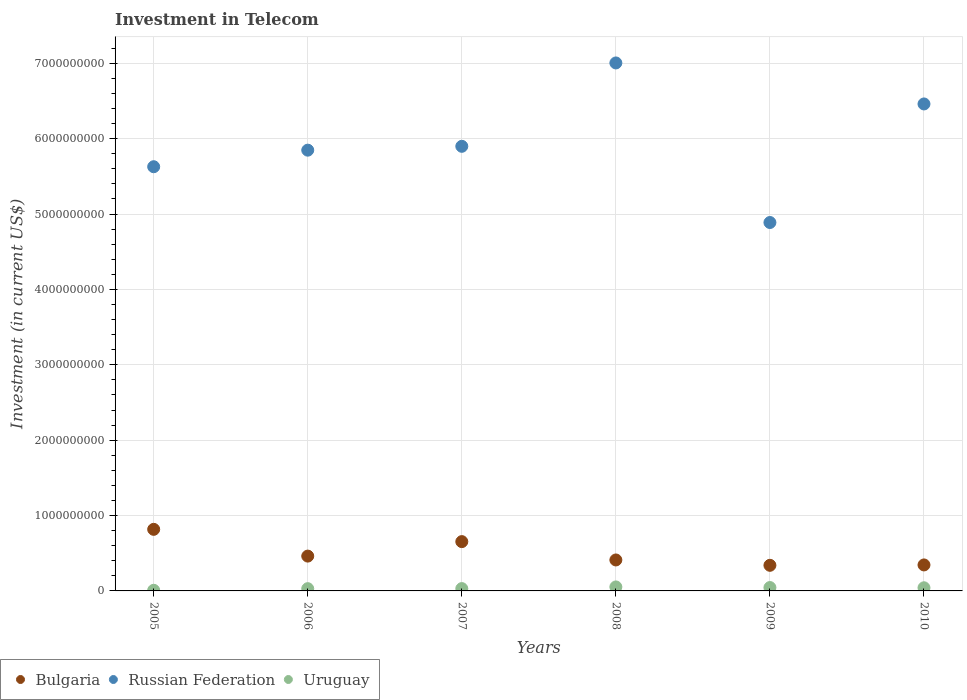How many different coloured dotlines are there?
Your response must be concise. 3. Is the number of dotlines equal to the number of legend labels?
Offer a very short reply. Yes. What is the amount invested in telecom in Russian Federation in 2006?
Give a very brief answer. 5.85e+09. Across all years, what is the maximum amount invested in telecom in Uruguay?
Provide a succinct answer. 5.29e+07. Across all years, what is the minimum amount invested in telecom in Uruguay?
Ensure brevity in your answer.  8.40e+06. What is the total amount invested in telecom in Russian Federation in the graph?
Provide a succinct answer. 3.57e+1. What is the difference between the amount invested in telecom in Bulgaria in 2005 and that in 2010?
Your answer should be compact. 4.72e+08. What is the difference between the amount invested in telecom in Bulgaria in 2006 and the amount invested in telecom in Russian Federation in 2005?
Your response must be concise. -5.17e+09. What is the average amount invested in telecom in Bulgaria per year?
Offer a very short reply. 5.05e+08. In the year 2010, what is the difference between the amount invested in telecom in Uruguay and amount invested in telecom in Russian Federation?
Offer a very short reply. -6.42e+09. What is the ratio of the amount invested in telecom in Bulgaria in 2006 to that in 2008?
Your answer should be very brief. 1.12. Is the difference between the amount invested in telecom in Uruguay in 2006 and 2010 greater than the difference between the amount invested in telecom in Russian Federation in 2006 and 2010?
Provide a short and direct response. Yes. What is the difference between the highest and the second highest amount invested in telecom in Bulgaria?
Make the answer very short. 1.63e+08. What is the difference between the highest and the lowest amount invested in telecom in Bulgaria?
Provide a short and direct response. 4.77e+08. In how many years, is the amount invested in telecom in Uruguay greater than the average amount invested in telecom in Uruguay taken over all years?
Make the answer very short. 3. Is the sum of the amount invested in telecom in Bulgaria in 2007 and 2009 greater than the maximum amount invested in telecom in Uruguay across all years?
Offer a terse response. Yes. Is it the case that in every year, the sum of the amount invested in telecom in Bulgaria and amount invested in telecom in Uruguay  is greater than the amount invested in telecom in Russian Federation?
Offer a terse response. No. Does the amount invested in telecom in Russian Federation monotonically increase over the years?
Offer a very short reply. No. Is the amount invested in telecom in Russian Federation strictly greater than the amount invested in telecom in Uruguay over the years?
Your answer should be very brief. Yes. Is the amount invested in telecom in Uruguay strictly less than the amount invested in telecom in Bulgaria over the years?
Ensure brevity in your answer.  Yes. How many years are there in the graph?
Make the answer very short. 6. Are the values on the major ticks of Y-axis written in scientific E-notation?
Offer a very short reply. No. How many legend labels are there?
Your response must be concise. 3. What is the title of the graph?
Offer a terse response. Investment in Telecom. What is the label or title of the Y-axis?
Make the answer very short. Investment (in current US$). What is the Investment (in current US$) in Bulgaria in 2005?
Your answer should be compact. 8.17e+08. What is the Investment (in current US$) in Russian Federation in 2005?
Give a very brief answer. 5.63e+09. What is the Investment (in current US$) of Uruguay in 2005?
Your answer should be very brief. 8.40e+06. What is the Investment (in current US$) of Bulgaria in 2006?
Offer a terse response. 4.62e+08. What is the Investment (in current US$) in Russian Federation in 2006?
Give a very brief answer. 5.85e+09. What is the Investment (in current US$) in Uruguay in 2006?
Your response must be concise. 3.00e+07. What is the Investment (in current US$) in Bulgaria in 2007?
Offer a very short reply. 6.54e+08. What is the Investment (in current US$) in Russian Federation in 2007?
Your response must be concise. 5.90e+09. What is the Investment (in current US$) of Uruguay in 2007?
Your answer should be very brief. 3.09e+07. What is the Investment (in current US$) of Bulgaria in 2008?
Give a very brief answer. 4.11e+08. What is the Investment (in current US$) in Russian Federation in 2008?
Ensure brevity in your answer.  7.00e+09. What is the Investment (in current US$) of Uruguay in 2008?
Provide a succinct answer. 5.29e+07. What is the Investment (in current US$) in Bulgaria in 2009?
Offer a terse response. 3.40e+08. What is the Investment (in current US$) of Russian Federation in 2009?
Offer a very short reply. 4.89e+09. What is the Investment (in current US$) in Uruguay in 2009?
Make the answer very short. 4.47e+07. What is the Investment (in current US$) in Bulgaria in 2010?
Offer a very short reply. 3.45e+08. What is the Investment (in current US$) of Russian Federation in 2010?
Offer a very short reply. 6.46e+09. What is the Investment (in current US$) in Uruguay in 2010?
Provide a succinct answer. 4.17e+07. Across all years, what is the maximum Investment (in current US$) of Bulgaria?
Offer a terse response. 8.17e+08. Across all years, what is the maximum Investment (in current US$) in Russian Federation?
Ensure brevity in your answer.  7.00e+09. Across all years, what is the maximum Investment (in current US$) of Uruguay?
Provide a succinct answer. 5.29e+07. Across all years, what is the minimum Investment (in current US$) of Bulgaria?
Give a very brief answer. 3.40e+08. Across all years, what is the minimum Investment (in current US$) of Russian Federation?
Your answer should be very brief. 4.89e+09. Across all years, what is the minimum Investment (in current US$) in Uruguay?
Provide a short and direct response. 8.40e+06. What is the total Investment (in current US$) of Bulgaria in the graph?
Your answer should be compact. 3.03e+09. What is the total Investment (in current US$) in Russian Federation in the graph?
Ensure brevity in your answer.  3.57e+1. What is the total Investment (in current US$) in Uruguay in the graph?
Provide a short and direct response. 2.09e+08. What is the difference between the Investment (in current US$) in Bulgaria in 2005 and that in 2006?
Give a very brief answer. 3.55e+08. What is the difference between the Investment (in current US$) of Russian Federation in 2005 and that in 2006?
Provide a short and direct response. -2.20e+08. What is the difference between the Investment (in current US$) in Uruguay in 2005 and that in 2006?
Provide a succinct answer. -2.16e+07. What is the difference between the Investment (in current US$) of Bulgaria in 2005 and that in 2007?
Offer a terse response. 1.63e+08. What is the difference between the Investment (in current US$) of Russian Federation in 2005 and that in 2007?
Your response must be concise. -2.71e+08. What is the difference between the Investment (in current US$) in Uruguay in 2005 and that in 2007?
Offer a terse response. -2.25e+07. What is the difference between the Investment (in current US$) in Bulgaria in 2005 and that in 2008?
Provide a short and direct response. 4.06e+08. What is the difference between the Investment (in current US$) in Russian Federation in 2005 and that in 2008?
Keep it short and to the point. -1.38e+09. What is the difference between the Investment (in current US$) of Uruguay in 2005 and that in 2008?
Provide a short and direct response. -4.45e+07. What is the difference between the Investment (in current US$) of Bulgaria in 2005 and that in 2009?
Keep it short and to the point. 4.77e+08. What is the difference between the Investment (in current US$) in Russian Federation in 2005 and that in 2009?
Provide a short and direct response. 7.40e+08. What is the difference between the Investment (in current US$) in Uruguay in 2005 and that in 2009?
Ensure brevity in your answer.  -3.63e+07. What is the difference between the Investment (in current US$) of Bulgaria in 2005 and that in 2010?
Keep it short and to the point. 4.72e+08. What is the difference between the Investment (in current US$) in Russian Federation in 2005 and that in 2010?
Provide a short and direct response. -8.33e+08. What is the difference between the Investment (in current US$) of Uruguay in 2005 and that in 2010?
Offer a very short reply. -3.33e+07. What is the difference between the Investment (in current US$) in Bulgaria in 2006 and that in 2007?
Your response must be concise. -1.92e+08. What is the difference between the Investment (in current US$) of Russian Federation in 2006 and that in 2007?
Ensure brevity in your answer.  -5.11e+07. What is the difference between the Investment (in current US$) of Uruguay in 2006 and that in 2007?
Make the answer very short. -9.00e+05. What is the difference between the Investment (in current US$) in Bulgaria in 2006 and that in 2008?
Your answer should be compact. 5.12e+07. What is the difference between the Investment (in current US$) in Russian Federation in 2006 and that in 2008?
Ensure brevity in your answer.  -1.16e+09. What is the difference between the Investment (in current US$) of Uruguay in 2006 and that in 2008?
Offer a very short reply. -2.29e+07. What is the difference between the Investment (in current US$) in Bulgaria in 2006 and that in 2009?
Offer a terse response. 1.22e+08. What is the difference between the Investment (in current US$) in Russian Federation in 2006 and that in 2009?
Provide a short and direct response. 9.60e+08. What is the difference between the Investment (in current US$) of Uruguay in 2006 and that in 2009?
Ensure brevity in your answer.  -1.47e+07. What is the difference between the Investment (in current US$) in Bulgaria in 2006 and that in 2010?
Keep it short and to the point. 1.17e+08. What is the difference between the Investment (in current US$) in Russian Federation in 2006 and that in 2010?
Your answer should be compact. -6.13e+08. What is the difference between the Investment (in current US$) of Uruguay in 2006 and that in 2010?
Offer a terse response. -1.17e+07. What is the difference between the Investment (in current US$) in Bulgaria in 2007 and that in 2008?
Ensure brevity in your answer.  2.43e+08. What is the difference between the Investment (in current US$) in Russian Federation in 2007 and that in 2008?
Make the answer very short. -1.11e+09. What is the difference between the Investment (in current US$) of Uruguay in 2007 and that in 2008?
Ensure brevity in your answer.  -2.20e+07. What is the difference between the Investment (in current US$) of Bulgaria in 2007 and that in 2009?
Keep it short and to the point. 3.14e+08. What is the difference between the Investment (in current US$) in Russian Federation in 2007 and that in 2009?
Your answer should be compact. 1.01e+09. What is the difference between the Investment (in current US$) in Uruguay in 2007 and that in 2009?
Provide a succinct answer. -1.38e+07. What is the difference between the Investment (in current US$) in Bulgaria in 2007 and that in 2010?
Offer a very short reply. 3.09e+08. What is the difference between the Investment (in current US$) in Russian Federation in 2007 and that in 2010?
Make the answer very short. -5.62e+08. What is the difference between the Investment (in current US$) of Uruguay in 2007 and that in 2010?
Give a very brief answer. -1.08e+07. What is the difference between the Investment (in current US$) of Bulgaria in 2008 and that in 2009?
Offer a very short reply. 7.11e+07. What is the difference between the Investment (in current US$) of Russian Federation in 2008 and that in 2009?
Offer a terse response. 2.12e+09. What is the difference between the Investment (in current US$) in Uruguay in 2008 and that in 2009?
Provide a short and direct response. 8.20e+06. What is the difference between the Investment (in current US$) of Bulgaria in 2008 and that in 2010?
Offer a terse response. 6.60e+07. What is the difference between the Investment (in current US$) in Russian Federation in 2008 and that in 2010?
Your answer should be compact. 5.44e+08. What is the difference between the Investment (in current US$) of Uruguay in 2008 and that in 2010?
Make the answer very short. 1.12e+07. What is the difference between the Investment (in current US$) in Bulgaria in 2009 and that in 2010?
Make the answer very short. -5.10e+06. What is the difference between the Investment (in current US$) of Russian Federation in 2009 and that in 2010?
Provide a short and direct response. -1.57e+09. What is the difference between the Investment (in current US$) in Uruguay in 2009 and that in 2010?
Your answer should be very brief. 3.00e+06. What is the difference between the Investment (in current US$) of Bulgaria in 2005 and the Investment (in current US$) of Russian Federation in 2006?
Provide a short and direct response. -5.03e+09. What is the difference between the Investment (in current US$) of Bulgaria in 2005 and the Investment (in current US$) of Uruguay in 2006?
Your answer should be very brief. 7.87e+08. What is the difference between the Investment (in current US$) of Russian Federation in 2005 and the Investment (in current US$) of Uruguay in 2006?
Your response must be concise. 5.60e+09. What is the difference between the Investment (in current US$) of Bulgaria in 2005 and the Investment (in current US$) of Russian Federation in 2007?
Provide a succinct answer. -5.08e+09. What is the difference between the Investment (in current US$) of Bulgaria in 2005 and the Investment (in current US$) of Uruguay in 2007?
Your answer should be compact. 7.86e+08. What is the difference between the Investment (in current US$) in Russian Federation in 2005 and the Investment (in current US$) in Uruguay in 2007?
Make the answer very short. 5.60e+09. What is the difference between the Investment (in current US$) in Bulgaria in 2005 and the Investment (in current US$) in Russian Federation in 2008?
Make the answer very short. -6.19e+09. What is the difference between the Investment (in current US$) of Bulgaria in 2005 and the Investment (in current US$) of Uruguay in 2008?
Provide a short and direct response. 7.64e+08. What is the difference between the Investment (in current US$) in Russian Federation in 2005 and the Investment (in current US$) in Uruguay in 2008?
Offer a terse response. 5.57e+09. What is the difference between the Investment (in current US$) in Bulgaria in 2005 and the Investment (in current US$) in Russian Federation in 2009?
Offer a very short reply. -4.07e+09. What is the difference between the Investment (in current US$) of Bulgaria in 2005 and the Investment (in current US$) of Uruguay in 2009?
Give a very brief answer. 7.72e+08. What is the difference between the Investment (in current US$) of Russian Federation in 2005 and the Investment (in current US$) of Uruguay in 2009?
Keep it short and to the point. 5.58e+09. What is the difference between the Investment (in current US$) of Bulgaria in 2005 and the Investment (in current US$) of Russian Federation in 2010?
Your answer should be very brief. -5.64e+09. What is the difference between the Investment (in current US$) of Bulgaria in 2005 and the Investment (in current US$) of Uruguay in 2010?
Your response must be concise. 7.75e+08. What is the difference between the Investment (in current US$) of Russian Federation in 2005 and the Investment (in current US$) of Uruguay in 2010?
Offer a very short reply. 5.59e+09. What is the difference between the Investment (in current US$) of Bulgaria in 2006 and the Investment (in current US$) of Russian Federation in 2007?
Your answer should be compact. -5.44e+09. What is the difference between the Investment (in current US$) of Bulgaria in 2006 and the Investment (in current US$) of Uruguay in 2007?
Provide a succinct answer. 4.31e+08. What is the difference between the Investment (in current US$) of Russian Federation in 2006 and the Investment (in current US$) of Uruguay in 2007?
Give a very brief answer. 5.82e+09. What is the difference between the Investment (in current US$) of Bulgaria in 2006 and the Investment (in current US$) of Russian Federation in 2008?
Your answer should be very brief. -6.54e+09. What is the difference between the Investment (in current US$) in Bulgaria in 2006 and the Investment (in current US$) in Uruguay in 2008?
Keep it short and to the point. 4.09e+08. What is the difference between the Investment (in current US$) in Russian Federation in 2006 and the Investment (in current US$) in Uruguay in 2008?
Provide a short and direct response. 5.79e+09. What is the difference between the Investment (in current US$) in Bulgaria in 2006 and the Investment (in current US$) in Russian Federation in 2009?
Provide a short and direct response. -4.43e+09. What is the difference between the Investment (in current US$) in Bulgaria in 2006 and the Investment (in current US$) in Uruguay in 2009?
Provide a succinct answer. 4.17e+08. What is the difference between the Investment (in current US$) in Russian Federation in 2006 and the Investment (in current US$) in Uruguay in 2009?
Provide a short and direct response. 5.80e+09. What is the difference between the Investment (in current US$) of Bulgaria in 2006 and the Investment (in current US$) of Russian Federation in 2010?
Your answer should be very brief. -6.00e+09. What is the difference between the Investment (in current US$) of Bulgaria in 2006 and the Investment (in current US$) of Uruguay in 2010?
Offer a terse response. 4.20e+08. What is the difference between the Investment (in current US$) in Russian Federation in 2006 and the Investment (in current US$) in Uruguay in 2010?
Ensure brevity in your answer.  5.81e+09. What is the difference between the Investment (in current US$) in Bulgaria in 2007 and the Investment (in current US$) in Russian Federation in 2008?
Your answer should be very brief. -6.35e+09. What is the difference between the Investment (in current US$) of Bulgaria in 2007 and the Investment (in current US$) of Uruguay in 2008?
Your answer should be compact. 6.01e+08. What is the difference between the Investment (in current US$) of Russian Federation in 2007 and the Investment (in current US$) of Uruguay in 2008?
Provide a succinct answer. 5.85e+09. What is the difference between the Investment (in current US$) of Bulgaria in 2007 and the Investment (in current US$) of Russian Federation in 2009?
Offer a very short reply. -4.23e+09. What is the difference between the Investment (in current US$) of Bulgaria in 2007 and the Investment (in current US$) of Uruguay in 2009?
Offer a very short reply. 6.09e+08. What is the difference between the Investment (in current US$) in Russian Federation in 2007 and the Investment (in current US$) in Uruguay in 2009?
Provide a short and direct response. 5.85e+09. What is the difference between the Investment (in current US$) in Bulgaria in 2007 and the Investment (in current US$) in Russian Federation in 2010?
Your answer should be compact. -5.81e+09. What is the difference between the Investment (in current US$) in Bulgaria in 2007 and the Investment (in current US$) in Uruguay in 2010?
Ensure brevity in your answer.  6.12e+08. What is the difference between the Investment (in current US$) of Russian Federation in 2007 and the Investment (in current US$) of Uruguay in 2010?
Provide a succinct answer. 5.86e+09. What is the difference between the Investment (in current US$) of Bulgaria in 2008 and the Investment (in current US$) of Russian Federation in 2009?
Keep it short and to the point. -4.48e+09. What is the difference between the Investment (in current US$) of Bulgaria in 2008 and the Investment (in current US$) of Uruguay in 2009?
Offer a terse response. 3.66e+08. What is the difference between the Investment (in current US$) in Russian Federation in 2008 and the Investment (in current US$) in Uruguay in 2009?
Offer a very short reply. 6.96e+09. What is the difference between the Investment (in current US$) in Bulgaria in 2008 and the Investment (in current US$) in Russian Federation in 2010?
Your answer should be compact. -6.05e+09. What is the difference between the Investment (in current US$) of Bulgaria in 2008 and the Investment (in current US$) of Uruguay in 2010?
Keep it short and to the point. 3.69e+08. What is the difference between the Investment (in current US$) of Russian Federation in 2008 and the Investment (in current US$) of Uruguay in 2010?
Offer a very short reply. 6.96e+09. What is the difference between the Investment (in current US$) in Bulgaria in 2009 and the Investment (in current US$) in Russian Federation in 2010?
Your answer should be very brief. -6.12e+09. What is the difference between the Investment (in current US$) in Bulgaria in 2009 and the Investment (in current US$) in Uruguay in 2010?
Offer a terse response. 2.98e+08. What is the difference between the Investment (in current US$) of Russian Federation in 2009 and the Investment (in current US$) of Uruguay in 2010?
Your response must be concise. 4.85e+09. What is the average Investment (in current US$) in Bulgaria per year?
Your answer should be compact. 5.05e+08. What is the average Investment (in current US$) of Russian Federation per year?
Your answer should be compact. 5.95e+09. What is the average Investment (in current US$) of Uruguay per year?
Your answer should be very brief. 3.48e+07. In the year 2005, what is the difference between the Investment (in current US$) of Bulgaria and Investment (in current US$) of Russian Federation?
Provide a short and direct response. -4.81e+09. In the year 2005, what is the difference between the Investment (in current US$) of Bulgaria and Investment (in current US$) of Uruguay?
Your answer should be very brief. 8.08e+08. In the year 2005, what is the difference between the Investment (in current US$) in Russian Federation and Investment (in current US$) in Uruguay?
Give a very brief answer. 5.62e+09. In the year 2006, what is the difference between the Investment (in current US$) in Bulgaria and Investment (in current US$) in Russian Federation?
Provide a succinct answer. -5.39e+09. In the year 2006, what is the difference between the Investment (in current US$) of Bulgaria and Investment (in current US$) of Uruguay?
Your answer should be very brief. 4.32e+08. In the year 2006, what is the difference between the Investment (in current US$) in Russian Federation and Investment (in current US$) in Uruguay?
Your answer should be compact. 5.82e+09. In the year 2007, what is the difference between the Investment (in current US$) of Bulgaria and Investment (in current US$) of Russian Federation?
Ensure brevity in your answer.  -5.24e+09. In the year 2007, what is the difference between the Investment (in current US$) of Bulgaria and Investment (in current US$) of Uruguay?
Make the answer very short. 6.23e+08. In the year 2007, what is the difference between the Investment (in current US$) of Russian Federation and Investment (in current US$) of Uruguay?
Offer a very short reply. 5.87e+09. In the year 2008, what is the difference between the Investment (in current US$) of Bulgaria and Investment (in current US$) of Russian Federation?
Ensure brevity in your answer.  -6.59e+09. In the year 2008, what is the difference between the Investment (in current US$) of Bulgaria and Investment (in current US$) of Uruguay?
Offer a very short reply. 3.58e+08. In the year 2008, what is the difference between the Investment (in current US$) in Russian Federation and Investment (in current US$) in Uruguay?
Keep it short and to the point. 6.95e+09. In the year 2009, what is the difference between the Investment (in current US$) in Bulgaria and Investment (in current US$) in Russian Federation?
Ensure brevity in your answer.  -4.55e+09. In the year 2009, what is the difference between the Investment (in current US$) in Bulgaria and Investment (in current US$) in Uruguay?
Keep it short and to the point. 2.95e+08. In the year 2009, what is the difference between the Investment (in current US$) of Russian Federation and Investment (in current US$) of Uruguay?
Your response must be concise. 4.84e+09. In the year 2010, what is the difference between the Investment (in current US$) in Bulgaria and Investment (in current US$) in Russian Federation?
Give a very brief answer. -6.12e+09. In the year 2010, what is the difference between the Investment (in current US$) in Bulgaria and Investment (in current US$) in Uruguay?
Provide a short and direct response. 3.03e+08. In the year 2010, what is the difference between the Investment (in current US$) in Russian Federation and Investment (in current US$) in Uruguay?
Keep it short and to the point. 6.42e+09. What is the ratio of the Investment (in current US$) in Bulgaria in 2005 to that in 2006?
Your answer should be very brief. 1.77. What is the ratio of the Investment (in current US$) of Russian Federation in 2005 to that in 2006?
Your answer should be compact. 0.96. What is the ratio of the Investment (in current US$) in Uruguay in 2005 to that in 2006?
Make the answer very short. 0.28. What is the ratio of the Investment (in current US$) in Bulgaria in 2005 to that in 2007?
Give a very brief answer. 1.25. What is the ratio of the Investment (in current US$) in Russian Federation in 2005 to that in 2007?
Keep it short and to the point. 0.95. What is the ratio of the Investment (in current US$) in Uruguay in 2005 to that in 2007?
Offer a terse response. 0.27. What is the ratio of the Investment (in current US$) in Bulgaria in 2005 to that in 2008?
Your answer should be compact. 1.99. What is the ratio of the Investment (in current US$) of Russian Federation in 2005 to that in 2008?
Offer a terse response. 0.8. What is the ratio of the Investment (in current US$) in Uruguay in 2005 to that in 2008?
Give a very brief answer. 0.16. What is the ratio of the Investment (in current US$) of Bulgaria in 2005 to that in 2009?
Offer a very short reply. 2.4. What is the ratio of the Investment (in current US$) of Russian Federation in 2005 to that in 2009?
Give a very brief answer. 1.15. What is the ratio of the Investment (in current US$) in Uruguay in 2005 to that in 2009?
Provide a short and direct response. 0.19. What is the ratio of the Investment (in current US$) of Bulgaria in 2005 to that in 2010?
Provide a short and direct response. 2.37. What is the ratio of the Investment (in current US$) of Russian Federation in 2005 to that in 2010?
Provide a short and direct response. 0.87. What is the ratio of the Investment (in current US$) in Uruguay in 2005 to that in 2010?
Offer a very short reply. 0.2. What is the ratio of the Investment (in current US$) of Bulgaria in 2006 to that in 2007?
Make the answer very short. 0.71. What is the ratio of the Investment (in current US$) of Uruguay in 2006 to that in 2007?
Provide a succinct answer. 0.97. What is the ratio of the Investment (in current US$) in Bulgaria in 2006 to that in 2008?
Your answer should be compact. 1.12. What is the ratio of the Investment (in current US$) of Russian Federation in 2006 to that in 2008?
Your response must be concise. 0.83. What is the ratio of the Investment (in current US$) in Uruguay in 2006 to that in 2008?
Your answer should be compact. 0.57. What is the ratio of the Investment (in current US$) in Bulgaria in 2006 to that in 2009?
Offer a terse response. 1.36. What is the ratio of the Investment (in current US$) in Russian Federation in 2006 to that in 2009?
Your answer should be very brief. 1.2. What is the ratio of the Investment (in current US$) of Uruguay in 2006 to that in 2009?
Your answer should be compact. 0.67. What is the ratio of the Investment (in current US$) in Bulgaria in 2006 to that in 2010?
Ensure brevity in your answer.  1.34. What is the ratio of the Investment (in current US$) of Russian Federation in 2006 to that in 2010?
Your answer should be very brief. 0.91. What is the ratio of the Investment (in current US$) of Uruguay in 2006 to that in 2010?
Your answer should be very brief. 0.72. What is the ratio of the Investment (in current US$) in Bulgaria in 2007 to that in 2008?
Your answer should be compact. 1.59. What is the ratio of the Investment (in current US$) of Russian Federation in 2007 to that in 2008?
Make the answer very short. 0.84. What is the ratio of the Investment (in current US$) in Uruguay in 2007 to that in 2008?
Your answer should be compact. 0.58. What is the ratio of the Investment (in current US$) of Bulgaria in 2007 to that in 2009?
Give a very brief answer. 1.93. What is the ratio of the Investment (in current US$) in Russian Federation in 2007 to that in 2009?
Your response must be concise. 1.21. What is the ratio of the Investment (in current US$) in Uruguay in 2007 to that in 2009?
Your answer should be compact. 0.69. What is the ratio of the Investment (in current US$) of Bulgaria in 2007 to that in 2010?
Your answer should be compact. 1.9. What is the ratio of the Investment (in current US$) in Uruguay in 2007 to that in 2010?
Your answer should be compact. 0.74. What is the ratio of the Investment (in current US$) in Bulgaria in 2008 to that in 2009?
Provide a short and direct response. 1.21. What is the ratio of the Investment (in current US$) in Russian Federation in 2008 to that in 2009?
Your answer should be compact. 1.43. What is the ratio of the Investment (in current US$) of Uruguay in 2008 to that in 2009?
Keep it short and to the point. 1.18. What is the ratio of the Investment (in current US$) of Bulgaria in 2008 to that in 2010?
Give a very brief answer. 1.19. What is the ratio of the Investment (in current US$) in Russian Federation in 2008 to that in 2010?
Offer a very short reply. 1.08. What is the ratio of the Investment (in current US$) in Uruguay in 2008 to that in 2010?
Keep it short and to the point. 1.27. What is the ratio of the Investment (in current US$) in Bulgaria in 2009 to that in 2010?
Ensure brevity in your answer.  0.99. What is the ratio of the Investment (in current US$) of Russian Federation in 2009 to that in 2010?
Give a very brief answer. 0.76. What is the ratio of the Investment (in current US$) of Uruguay in 2009 to that in 2010?
Ensure brevity in your answer.  1.07. What is the difference between the highest and the second highest Investment (in current US$) of Bulgaria?
Offer a very short reply. 1.63e+08. What is the difference between the highest and the second highest Investment (in current US$) of Russian Federation?
Make the answer very short. 5.44e+08. What is the difference between the highest and the second highest Investment (in current US$) in Uruguay?
Offer a very short reply. 8.20e+06. What is the difference between the highest and the lowest Investment (in current US$) of Bulgaria?
Give a very brief answer. 4.77e+08. What is the difference between the highest and the lowest Investment (in current US$) in Russian Federation?
Provide a short and direct response. 2.12e+09. What is the difference between the highest and the lowest Investment (in current US$) in Uruguay?
Ensure brevity in your answer.  4.45e+07. 